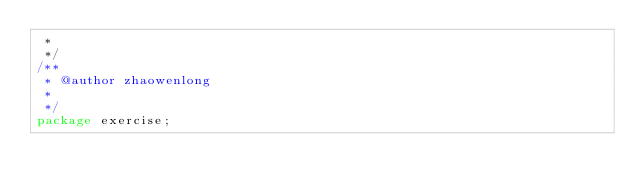Convert code to text. <code><loc_0><loc_0><loc_500><loc_500><_Java_> * 
 */
/**
 * @author zhaowenlong
 *
 */
package exercise;</code> 